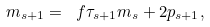<formula> <loc_0><loc_0><loc_500><loc_500>m _ { s + 1 } = \ f { \tau _ { s + 1 } } { m _ { s } } + 2 p _ { s + 1 } ,</formula> 